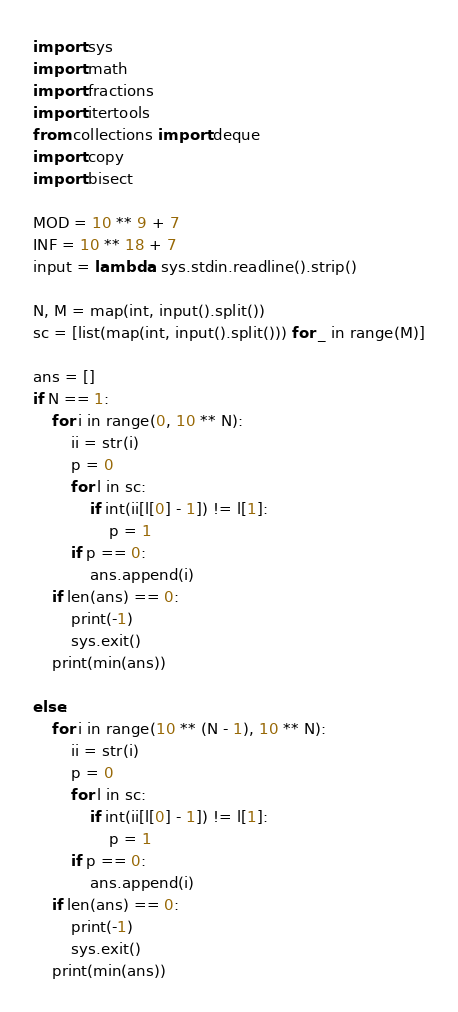<code> <loc_0><loc_0><loc_500><loc_500><_Python_>import sys
import math
import fractions
import itertools
from collections import deque
import copy
import bisect

MOD = 10 ** 9 + 7
INF = 10 ** 18 + 7
input = lambda: sys.stdin.readline().strip()

N, M = map(int, input().split())
sc = [list(map(int, input().split())) for _ in range(M)]

ans = []
if N == 1:
    for i in range(0, 10 ** N):
        ii = str(i)
        p = 0
        for l in sc:
            if int(ii[l[0] - 1]) != l[1]:
                p = 1
        if p == 0:
            ans.append(i)
    if len(ans) == 0:
        print(-1)
        sys.exit()
    print(min(ans))

else:
    for i in range(10 ** (N - 1), 10 ** N):
        ii = str(i)
        p = 0
        for l in sc:
            if int(ii[l[0] - 1]) != l[1]:
                p = 1
        if p == 0:
            ans.append(i)
    if len(ans) == 0:
        print(-1)
        sys.exit()
    print(min(ans))

</code> 